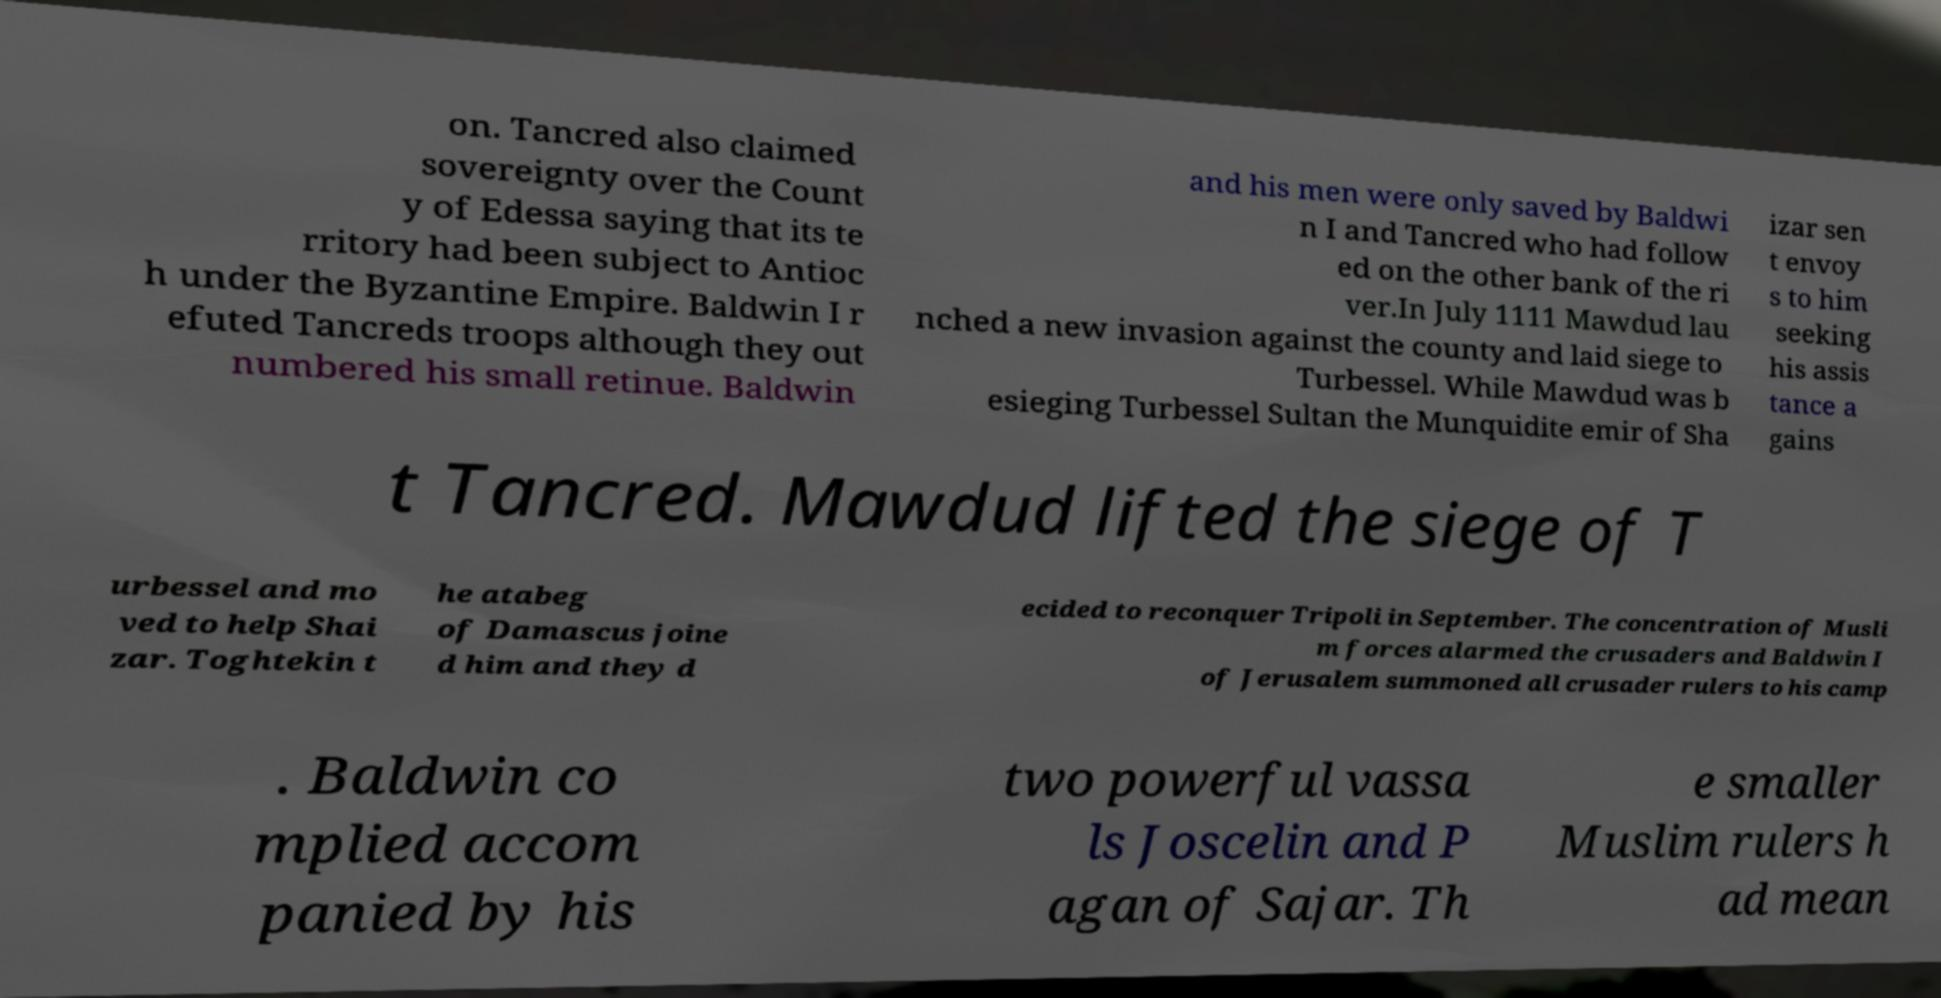Could you extract and type out the text from this image? on. Tancred also claimed sovereignty over the Count y of Edessa saying that its te rritory had been subject to Antioc h under the Byzantine Empire. Baldwin I r efuted Tancreds troops although they out numbered his small retinue. Baldwin and his men were only saved by Baldwi n I and Tancred who had follow ed on the other bank of the ri ver.In July 1111 Mawdud lau nched a new invasion against the county and laid siege to Turbessel. While Mawdud was b esieging Turbessel Sultan the Munquidite emir of Sha izar sen t envoy s to him seeking his assis tance a gains t Tancred. Mawdud lifted the siege of T urbessel and mo ved to help Shai zar. Toghtekin t he atabeg of Damascus joine d him and they d ecided to reconquer Tripoli in September. The concentration of Musli m forces alarmed the crusaders and Baldwin I of Jerusalem summoned all crusader rulers to his camp . Baldwin co mplied accom panied by his two powerful vassa ls Joscelin and P agan of Sajar. Th e smaller Muslim rulers h ad mean 